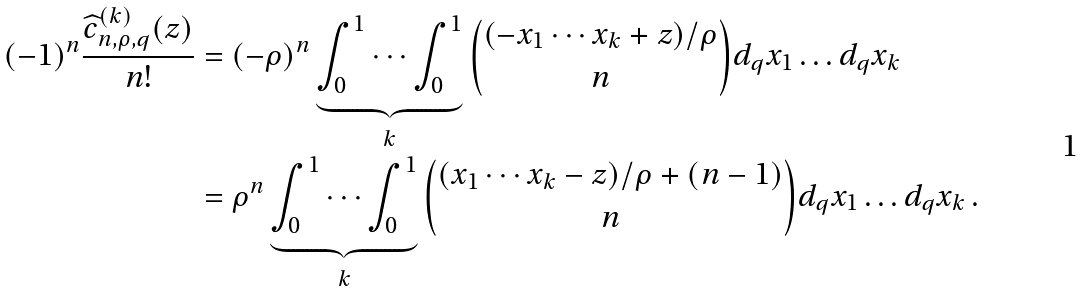Convert formula to latex. <formula><loc_0><loc_0><loc_500><loc_500>( - 1 ) ^ { n } \frac { \widehat { c } _ { n , \rho , q } ^ { ( k ) } ( z ) } { n ! } & = ( - \rho ) ^ { n } \underbrace { \int _ { 0 } ^ { 1 } \cdots \int _ { 0 } ^ { 1 } } _ { k } \binom { ( - x _ { 1 } \cdots x _ { k } + z ) / \rho } { n } d _ { q } x _ { 1 } \dots d _ { q } x _ { k } \\ & = \rho ^ { n } \underbrace { \int _ { 0 } ^ { 1 } \cdots \int _ { 0 } ^ { 1 } } _ { k } \binom { ( x _ { 1 } \cdots x _ { k } - z ) / \rho + ( n - 1 ) } { n } d _ { q } x _ { 1 } \dots d _ { q } x _ { k } \, .</formula> 